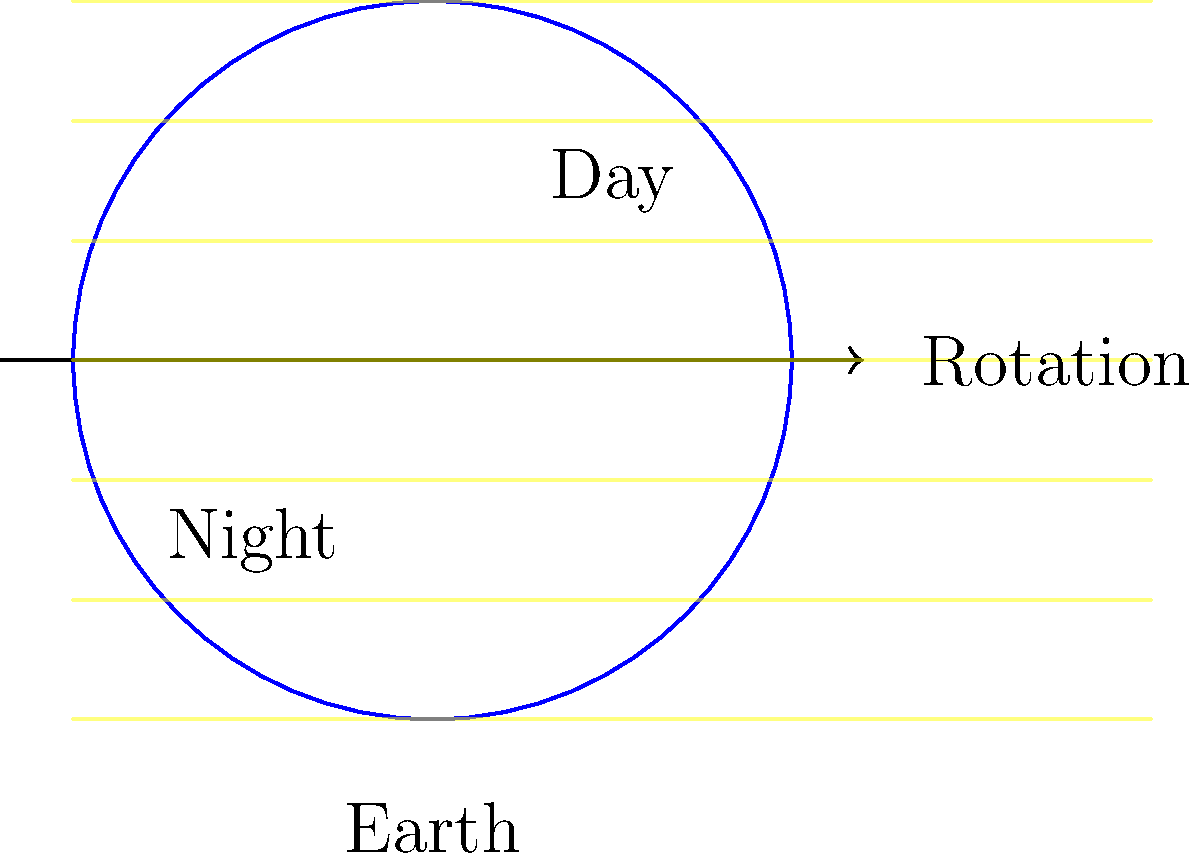As you engage with border patrol agents to discuss global perspectives, you want to explain the basics of Earth's rotation. Using the illustration provided, how long does it take for a point on Earth's surface to complete one full rotation from day to night and back to day again? Let's break this down step-by-step:

1. The illustration shows a simplified model of Earth rotating on its axis.

2. The left side of the Earth is in darkness (night), while the right side is illuminated by the Sun's rays (day).

3. Earth rotates on its axis from west to east, which is counterclockwise when viewed from above the North Pole.

4. As Earth rotates, a point on its surface moves from the day side to the night side and back to the day side.

5. This complete rotation is what defines a solar day on Earth.

6. The time it takes for Earth to complete one full rotation relative to the Sun is approximately 24 hours.

7. This 24-hour period is why we experience a full cycle of day and night in one Earth day.

It's important to note that while Earth's rotation period (sidereal day) is actually about 23 hours, 56 minutes, and 4 seconds, the solar day we use in everyday life is 24 hours due to Earth's orbital motion around the Sun.
Answer: 24 hours 